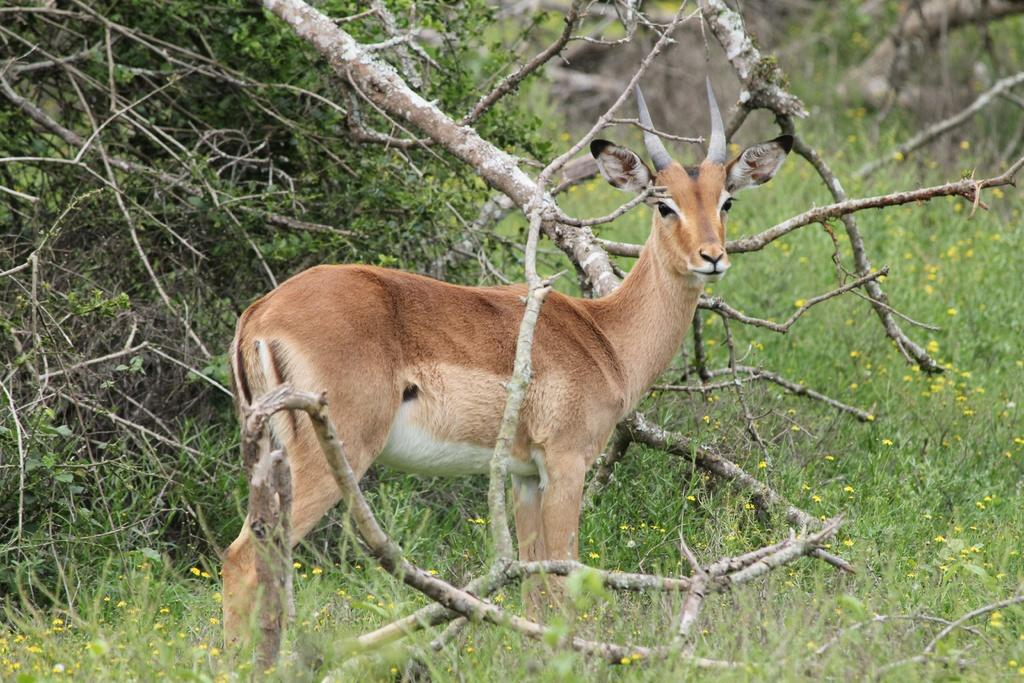What is the main subject in the center of the image? There is an animal in the center of the image. What type of vegetation is present at the bottom of the image? There is grass at the bottom of the image. What can be seen on the left side of the image? There is a heap of sticks on the left side of the image. How many apples are being served on the pizzas in the image? There are no apples or pizzas present in the image. 